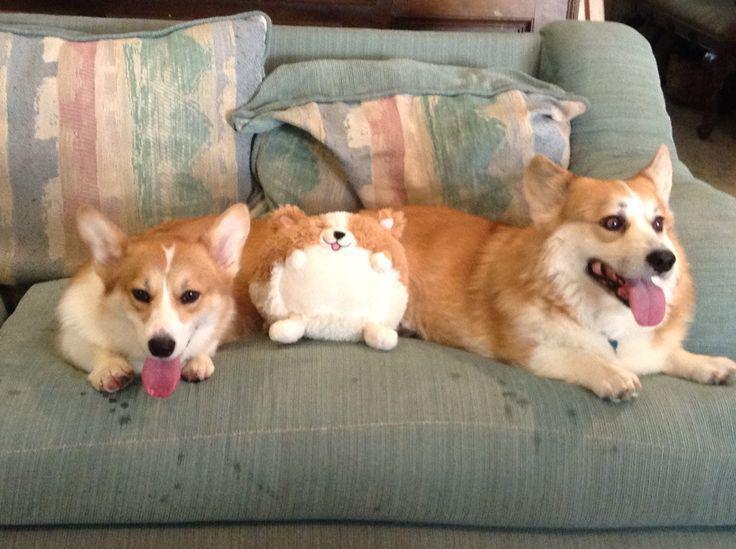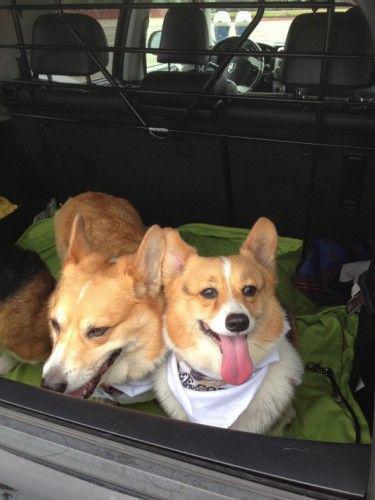The first image is the image on the left, the second image is the image on the right. Considering the images on both sides, is "There is two dogs in the right image." valid? Answer yes or no. Yes. The first image is the image on the left, the second image is the image on the right. Analyze the images presented: Is the assertion "All dogs are wearing costumes, and at least three dogs are wearing black-and-yellow bee costumes." valid? Answer yes or no. No. 